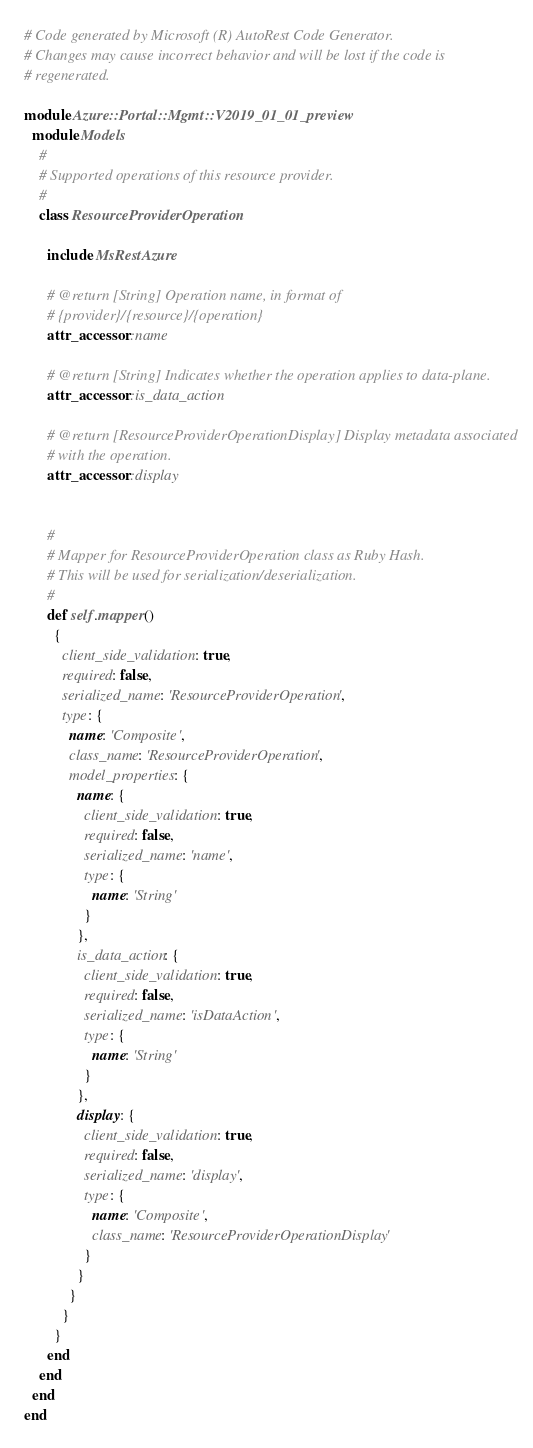Convert code to text. <code><loc_0><loc_0><loc_500><loc_500><_Ruby_># Code generated by Microsoft (R) AutoRest Code Generator.
# Changes may cause incorrect behavior and will be lost if the code is
# regenerated.

module Azure::Portal::Mgmt::V2019_01_01_preview
  module Models
    #
    # Supported operations of this resource provider.
    #
    class ResourceProviderOperation

      include MsRestAzure

      # @return [String] Operation name, in format of
      # {provider}/{resource}/{operation}
      attr_accessor :name

      # @return [String] Indicates whether the operation applies to data-plane.
      attr_accessor :is_data_action

      # @return [ResourceProviderOperationDisplay] Display metadata associated
      # with the operation.
      attr_accessor :display


      #
      # Mapper for ResourceProviderOperation class as Ruby Hash.
      # This will be used for serialization/deserialization.
      #
      def self.mapper()
        {
          client_side_validation: true,
          required: false,
          serialized_name: 'ResourceProviderOperation',
          type: {
            name: 'Composite',
            class_name: 'ResourceProviderOperation',
            model_properties: {
              name: {
                client_side_validation: true,
                required: false,
                serialized_name: 'name',
                type: {
                  name: 'String'
                }
              },
              is_data_action: {
                client_side_validation: true,
                required: false,
                serialized_name: 'isDataAction',
                type: {
                  name: 'String'
                }
              },
              display: {
                client_side_validation: true,
                required: false,
                serialized_name: 'display',
                type: {
                  name: 'Composite',
                  class_name: 'ResourceProviderOperationDisplay'
                }
              }
            }
          }
        }
      end
    end
  end
end
</code> 